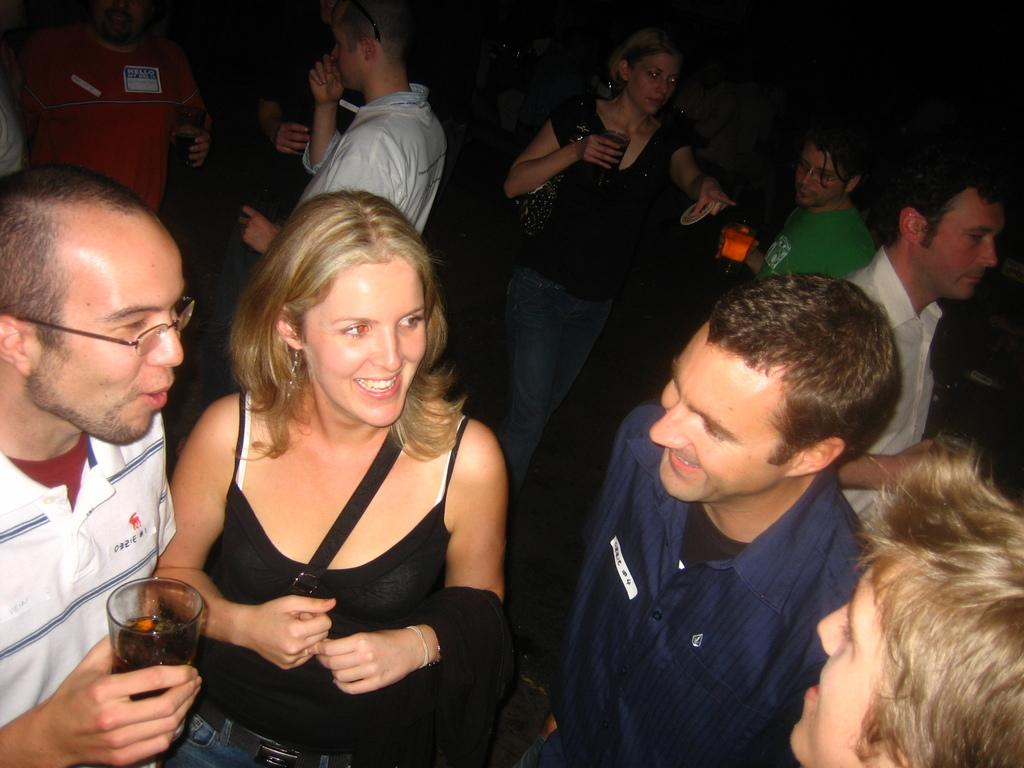What is the main subject of the image? The main subject of the image is a group of people. What are some of the people in the group doing? Some people in the group are holding glasses. How would you describe the background of the image? The background of the image is dark. How many trees can be seen in the image? There are no trees visible in the image; it features a group of people with some holding glasses, and the background is dark. 